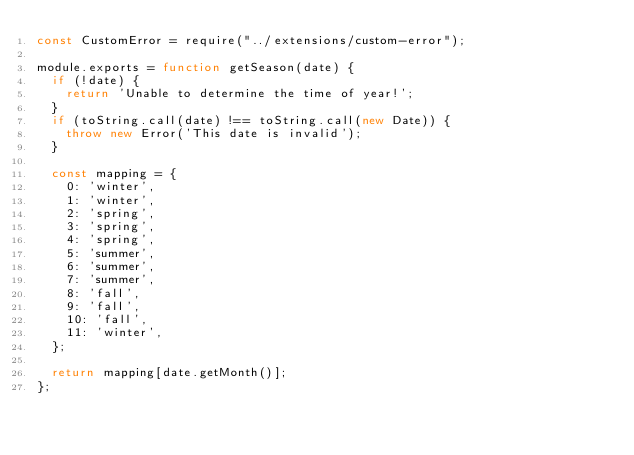Convert code to text. <code><loc_0><loc_0><loc_500><loc_500><_JavaScript_>const CustomError = require("../extensions/custom-error");

module.exports = function getSeason(date) {
  if (!date) {
    return 'Unable to determine the time of year!';
  }
  if (toString.call(date) !== toString.call(new Date)) {
    throw new Error('This date is invalid');
  }

  const mapping = {
    0: 'winter',
    1: 'winter',
    2: 'spring',
    3: 'spring',
    4: 'spring',
    5: 'summer',
    6: 'summer',
    7: 'summer',
    8: 'fall',
    9: 'fall',
    10: 'fall',
    11: 'winter',
  };

  return mapping[date.getMonth()];
};
</code> 